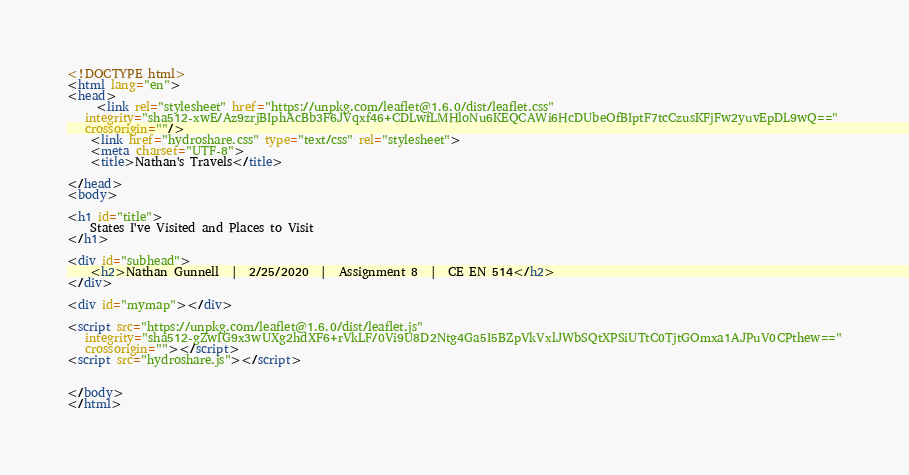Convert code to text. <code><loc_0><loc_0><loc_500><loc_500><_HTML_><!DOCTYPE html>
<html lang="en">
<head>
     <link rel="stylesheet" href="https://unpkg.com/leaflet@1.6.0/dist/leaflet.css"
   integrity="sha512-xwE/Az9zrjBIphAcBb3F6JVqxf46+CDLwfLMHloNu6KEQCAWi6HcDUbeOfBIptF7tcCzusKFjFw2yuvEpDL9wQ=="
   crossorigin=""/>
    <link href="hydroshare.css" type="text/css" rel="stylesheet">
    <meta charset="UTF-8">
    <title>Nathan's Travels</title>

</head>
<body>

<h1 id="title">
    States I've Visited and Places to Visit
</h1>

<div id="subhead">
    <h2>Nathan Gunnell  |  2/25/2020  |  Assignment 8  |  CE EN 514</h2>
</div>

<div id="mymap"></div>

<script src="https://unpkg.com/leaflet@1.6.0/dist/leaflet.js"
   integrity="sha512-gZwIG9x3wUXg2hdXF6+rVkLF/0Vi9U8D2Ntg4Ga5I5BZpVkVxlJWbSQtXPSiUTtC0TjtGOmxa1AJPuV0CPthew=="
   crossorigin=""></script>
<script src="hydroshare.js"></script>


</body>
</html></code> 